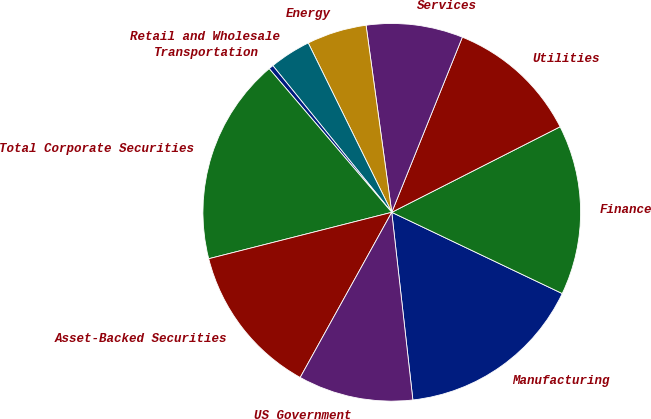Convert chart to OTSL. <chart><loc_0><loc_0><loc_500><loc_500><pie_chart><fcel>Manufacturing<fcel>Finance<fcel>Utilities<fcel>Services<fcel>Energy<fcel>Retail and Wholesale<fcel>Transportation<fcel>Total Corporate Securities<fcel>Asset-Backed Securities<fcel>US Government<nl><fcel>16.14%<fcel>14.56%<fcel>11.42%<fcel>8.27%<fcel>5.12%<fcel>3.55%<fcel>0.4%<fcel>17.71%<fcel>12.99%<fcel>9.84%<nl></chart> 